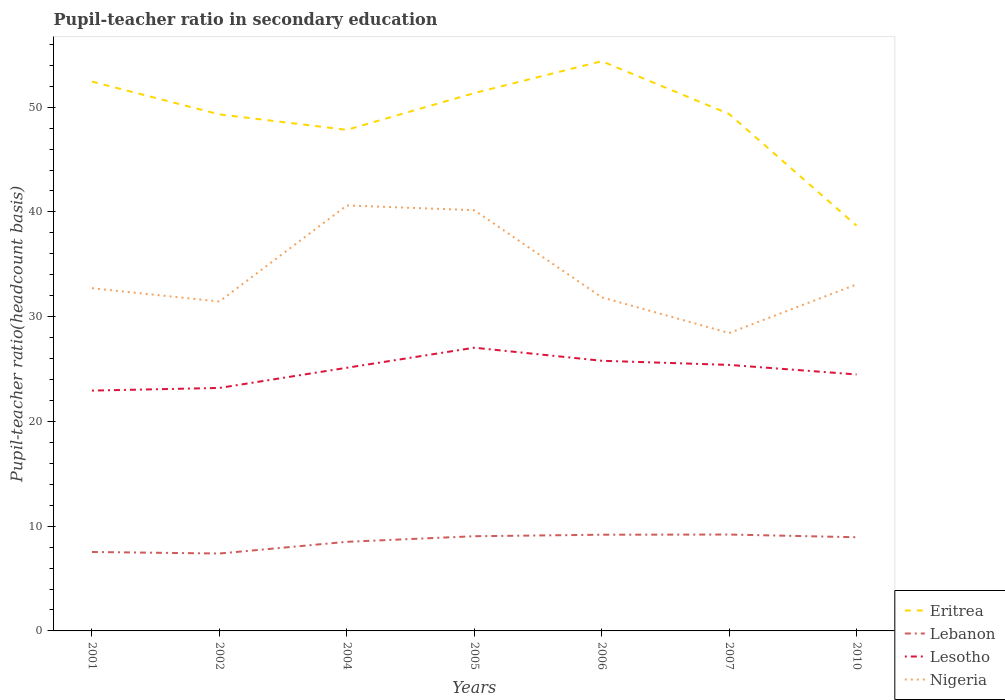How many different coloured lines are there?
Keep it short and to the point. 4. Across all years, what is the maximum pupil-teacher ratio in secondary education in Nigeria?
Your response must be concise. 28.44. In which year was the pupil-teacher ratio in secondary education in Lebanon maximum?
Provide a succinct answer. 2002. What is the total pupil-teacher ratio in secondary education in Lebanon in the graph?
Offer a terse response. -0.68. What is the difference between the highest and the second highest pupil-teacher ratio in secondary education in Nigeria?
Your answer should be very brief. 12.18. What is the difference between the highest and the lowest pupil-teacher ratio in secondary education in Eritrea?
Offer a terse response. 5. Is the pupil-teacher ratio in secondary education in Nigeria strictly greater than the pupil-teacher ratio in secondary education in Eritrea over the years?
Your answer should be compact. Yes. Does the graph contain grids?
Provide a succinct answer. No. How are the legend labels stacked?
Offer a very short reply. Vertical. What is the title of the graph?
Ensure brevity in your answer.  Pupil-teacher ratio in secondary education. Does "Malawi" appear as one of the legend labels in the graph?
Your response must be concise. No. What is the label or title of the Y-axis?
Give a very brief answer. Pupil-teacher ratio(headcount basis). What is the Pupil-teacher ratio(headcount basis) in Eritrea in 2001?
Your answer should be compact. 52.44. What is the Pupil-teacher ratio(headcount basis) in Lebanon in 2001?
Give a very brief answer. 7.54. What is the Pupil-teacher ratio(headcount basis) of Lesotho in 2001?
Offer a very short reply. 22.94. What is the Pupil-teacher ratio(headcount basis) of Nigeria in 2001?
Provide a succinct answer. 32.72. What is the Pupil-teacher ratio(headcount basis) in Eritrea in 2002?
Offer a very short reply. 49.31. What is the Pupil-teacher ratio(headcount basis) of Lebanon in 2002?
Make the answer very short. 7.39. What is the Pupil-teacher ratio(headcount basis) of Lesotho in 2002?
Your answer should be very brief. 23.2. What is the Pupil-teacher ratio(headcount basis) in Nigeria in 2002?
Ensure brevity in your answer.  31.44. What is the Pupil-teacher ratio(headcount basis) of Eritrea in 2004?
Make the answer very short. 47.84. What is the Pupil-teacher ratio(headcount basis) in Lebanon in 2004?
Provide a succinct answer. 8.51. What is the Pupil-teacher ratio(headcount basis) in Lesotho in 2004?
Keep it short and to the point. 25.12. What is the Pupil-teacher ratio(headcount basis) in Nigeria in 2004?
Keep it short and to the point. 40.62. What is the Pupil-teacher ratio(headcount basis) in Eritrea in 2005?
Make the answer very short. 51.35. What is the Pupil-teacher ratio(headcount basis) of Lebanon in 2005?
Ensure brevity in your answer.  9.04. What is the Pupil-teacher ratio(headcount basis) of Lesotho in 2005?
Your answer should be compact. 27.04. What is the Pupil-teacher ratio(headcount basis) in Nigeria in 2005?
Offer a terse response. 40.16. What is the Pupil-teacher ratio(headcount basis) of Eritrea in 2006?
Offer a very short reply. 54.39. What is the Pupil-teacher ratio(headcount basis) of Lebanon in 2006?
Keep it short and to the point. 9.18. What is the Pupil-teacher ratio(headcount basis) in Lesotho in 2006?
Your response must be concise. 25.79. What is the Pupil-teacher ratio(headcount basis) of Nigeria in 2006?
Keep it short and to the point. 31.85. What is the Pupil-teacher ratio(headcount basis) of Eritrea in 2007?
Give a very brief answer. 49.35. What is the Pupil-teacher ratio(headcount basis) of Lebanon in 2007?
Ensure brevity in your answer.  9.2. What is the Pupil-teacher ratio(headcount basis) in Lesotho in 2007?
Give a very brief answer. 25.4. What is the Pupil-teacher ratio(headcount basis) of Nigeria in 2007?
Ensure brevity in your answer.  28.44. What is the Pupil-teacher ratio(headcount basis) of Eritrea in 2010?
Your answer should be very brief. 38.68. What is the Pupil-teacher ratio(headcount basis) in Lebanon in 2010?
Provide a succinct answer. 8.94. What is the Pupil-teacher ratio(headcount basis) of Lesotho in 2010?
Ensure brevity in your answer.  24.48. What is the Pupil-teacher ratio(headcount basis) of Nigeria in 2010?
Your answer should be very brief. 33.08. Across all years, what is the maximum Pupil-teacher ratio(headcount basis) in Eritrea?
Make the answer very short. 54.39. Across all years, what is the maximum Pupil-teacher ratio(headcount basis) in Lebanon?
Your response must be concise. 9.2. Across all years, what is the maximum Pupil-teacher ratio(headcount basis) in Lesotho?
Offer a very short reply. 27.04. Across all years, what is the maximum Pupil-teacher ratio(headcount basis) of Nigeria?
Offer a terse response. 40.62. Across all years, what is the minimum Pupil-teacher ratio(headcount basis) in Eritrea?
Ensure brevity in your answer.  38.68. Across all years, what is the minimum Pupil-teacher ratio(headcount basis) in Lebanon?
Ensure brevity in your answer.  7.39. Across all years, what is the minimum Pupil-teacher ratio(headcount basis) in Lesotho?
Provide a short and direct response. 22.94. Across all years, what is the minimum Pupil-teacher ratio(headcount basis) in Nigeria?
Ensure brevity in your answer.  28.44. What is the total Pupil-teacher ratio(headcount basis) in Eritrea in the graph?
Provide a short and direct response. 343.37. What is the total Pupil-teacher ratio(headcount basis) in Lebanon in the graph?
Keep it short and to the point. 59.8. What is the total Pupil-teacher ratio(headcount basis) in Lesotho in the graph?
Your answer should be compact. 173.97. What is the total Pupil-teacher ratio(headcount basis) of Nigeria in the graph?
Keep it short and to the point. 238.32. What is the difference between the Pupil-teacher ratio(headcount basis) of Eritrea in 2001 and that in 2002?
Your response must be concise. 3.13. What is the difference between the Pupil-teacher ratio(headcount basis) in Lebanon in 2001 and that in 2002?
Give a very brief answer. 0.15. What is the difference between the Pupil-teacher ratio(headcount basis) in Lesotho in 2001 and that in 2002?
Your answer should be compact. -0.25. What is the difference between the Pupil-teacher ratio(headcount basis) of Nigeria in 2001 and that in 2002?
Your answer should be compact. 1.27. What is the difference between the Pupil-teacher ratio(headcount basis) in Eritrea in 2001 and that in 2004?
Your answer should be compact. 4.61. What is the difference between the Pupil-teacher ratio(headcount basis) in Lebanon in 2001 and that in 2004?
Your answer should be compact. -0.97. What is the difference between the Pupil-teacher ratio(headcount basis) in Lesotho in 2001 and that in 2004?
Offer a terse response. -2.18. What is the difference between the Pupil-teacher ratio(headcount basis) in Nigeria in 2001 and that in 2004?
Provide a short and direct response. -7.9. What is the difference between the Pupil-teacher ratio(headcount basis) in Eritrea in 2001 and that in 2005?
Offer a terse response. 1.1. What is the difference between the Pupil-teacher ratio(headcount basis) of Lebanon in 2001 and that in 2005?
Give a very brief answer. -1.5. What is the difference between the Pupil-teacher ratio(headcount basis) of Lesotho in 2001 and that in 2005?
Your answer should be compact. -4.1. What is the difference between the Pupil-teacher ratio(headcount basis) in Nigeria in 2001 and that in 2005?
Your answer should be very brief. -7.45. What is the difference between the Pupil-teacher ratio(headcount basis) in Eritrea in 2001 and that in 2006?
Your answer should be compact. -1.95. What is the difference between the Pupil-teacher ratio(headcount basis) of Lebanon in 2001 and that in 2006?
Your response must be concise. -1.65. What is the difference between the Pupil-teacher ratio(headcount basis) of Lesotho in 2001 and that in 2006?
Your answer should be compact. -2.85. What is the difference between the Pupil-teacher ratio(headcount basis) of Nigeria in 2001 and that in 2006?
Provide a short and direct response. 0.87. What is the difference between the Pupil-teacher ratio(headcount basis) in Eritrea in 2001 and that in 2007?
Your answer should be very brief. 3.1. What is the difference between the Pupil-teacher ratio(headcount basis) of Lebanon in 2001 and that in 2007?
Provide a succinct answer. -1.67. What is the difference between the Pupil-teacher ratio(headcount basis) in Lesotho in 2001 and that in 2007?
Give a very brief answer. -2.45. What is the difference between the Pupil-teacher ratio(headcount basis) in Nigeria in 2001 and that in 2007?
Give a very brief answer. 4.28. What is the difference between the Pupil-teacher ratio(headcount basis) in Eritrea in 2001 and that in 2010?
Your answer should be very brief. 13.76. What is the difference between the Pupil-teacher ratio(headcount basis) in Lebanon in 2001 and that in 2010?
Make the answer very short. -1.41. What is the difference between the Pupil-teacher ratio(headcount basis) of Lesotho in 2001 and that in 2010?
Keep it short and to the point. -1.54. What is the difference between the Pupil-teacher ratio(headcount basis) of Nigeria in 2001 and that in 2010?
Provide a short and direct response. -0.36. What is the difference between the Pupil-teacher ratio(headcount basis) of Eritrea in 2002 and that in 2004?
Offer a terse response. 1.48. What is the difference between the Pupil-teacher ratio(headcount basis) of Lebanon in 2002 and that in 2004?
Your answer should be compact. -1.12. What is the difference between the Pupil-teacher ratio(headcount basis) in Lesotho in 2002 and that in 2004?
Provide a short and direct response. -1.93. What is the difference between the Pupil-teacher ratio(headcount basis) in Nigeria in 2002 and that in 2004?
Keep it short and to the point. -9.17. What is the difference between the Pupil-teacher ratio(headcount basis) in Eritrea in 2002 and that in 2005?
Offer a very short reply. -2.03. What is the difference between the Pupil-teacher ratio(headcount basis) of Lebanon in 2002 and that in 2005?
Provide a succinct answer. -1.65. What is the difference between the Pupil-teacher ratio(headcount basis) of Lesotho in 2002 and that in 2005?
Offer a terse response. -3.84. What is the difference between the Pupil-teacher ratio(headcount basis) in Nigeria in 2002 and that in 2005?
Make the answer very short. -8.72. What is the difference between the Pupil-teacher ratio(headcount basis) in Eritrea in 2002 and that in 2006?
Your answer should be compact. -5.08. What is the difference between the Pupil-teacher ratio(headcount basis) of Lebanon in 2002 and that in 2006?
Your answer should be very brief. -1.79. What is the difference between the Pupil-teacher ratio(headcount basis) in Lesotho in 2002 and that in 2006?
Keep it short and to the point. -2.59. What is the difference between the Pupil-teacher ratio(headcount basis) in Nigeria in 2002 and that in 2006?
Make the answer very short. -0.41. What is the difference between the Pupil-teacher ratio(headcount basis) in Eritrea in 2002 and that in 2007?
Your response must be concise. -0.04. What is the difference between the Pupil-teacher ratio(headcount basis) in Lebanon in 2002 and that in 2007?
Provide a succinct answer. -1.81. What is the difference between the Pupil-teacher ratio(headcount basis) in Lesotho in 2002 and that in 2007?
Ensure brevity in your answer.  -2.2. What is the difference between the Pupil-teacher ratio(headcount basis) in Nigeria in 2002 and that in 2007?
Offer a very short reply. 3. What is the difference between the Pupil-teacher ratio(headcount basis) in Eritrea in 2002 and that in 2010?
Provide a short and direct response. 10.63. What is the difference between the Pupil-teacher ratio(headcount basis) in Lebanon in 2002 and that in 2010?
Your answer should be very brief. -1.55. What is the difference between the Pupil-teacher ratio(headcount basis) in Lesotho in 2002 and that in 2010?
Provide a succinct answer. -1.29. What is the difference between the Pupil-teacher ratio(headcount basis) in Nigeria in 2002 and that in 2010?
Keep it short and to the point. -1.64. What is the difference between the Pupil-teacher ratio(headcount basis) in Eritrea in 2004 and that in 2005?
Give a very brief answer. -3.51. What is the difference between the Pupil-teacher ratio(headcount basis) in Lebanon in 2004 and that in 2005?
Your answer should be compact. -0.53. What is the difference between the Pupil-teacher ratio(headcount basis) of Lesotho in 2004 and that in 2005?
Offer a very short reply. -1.91. What is the difference between the Pupil-teacher ratio(headcount basis) of Nigeria in 2004 and that in 2005?
Provide a succinct answer. 0.45. What is the difference between the Pupil-teacher ratio(headcount basis) in Eritrea in 2004 and that in 2006?
Your answer should be compact. -6.55. What is the difference between the Pupil-teacher ratio(headcount basis) in Lebanon in 2004 and that in 2006?
Your answer should be very brief. -0.68. What is the difference between the Pupil-teacher ratio(headcount basis) of Lesotho in 2004 and that in 2006?
Provide a short and direct response. -0.67. What is the difference between the Pupil-teacher ratio(headcount basis) in Nigeria in 2004 and that in 2006?
Ensure brevity in your answer.  8.77. What is the difference between the Pupil-teacher ratio(headcount basis) in Eritrea in 2004 and that in 2007?
Provide a succinct answer. -1.51. What is the difference between the Pupil-teacher ratio(headcount basis) of Lebanon in 2004 and that in 2007?
Offer a very short reply. -0.7. What is the difference between the Pupil-teacher ratio(headcount basis) of Lesotho in 2004 and that in 2007?
Offer a very short reply. -0.27. What is the difference between the Pupil-teacher ratio(headcount basis) of Nigeria in 2004 and that in 2007?
Offer a terse response. 12.18. What is the difference between the Pupil-teacher ratio(headcount basis) in Eritrea in 2004 and that in 2010?
Offer a terse response. 9.15. What is the difference between the Pupil-teacher ratio(headcount basis) of Lebanon in 2004 and that in 2010?
Ensure brevity in your answer.  -0.43. What is the difference between the Pupil-teacher ratio(headcount basis) of Lesotho in 2004 and that in 2010?
Provide a short and direct response. 0.64. What is the difference between the Pupil-teacher ratio(headcount basis) in Nigeria in 2004 and that in 2010?
Offer a terse response. 7.54. What is the difference between the Pupil-teacher ratio(headcount basis) of Eritrea in 2005 and that in 2006?
Make the answer very short. -3.04. What is the difference between the Pupil-teacher ratio(headcount basis) of Lebanon in 2005 and that in 2006?
Provide a succinct answer. -0.14. What is the difference between the Pupil-teacher ratio(headcount basis) in Lesotho in 2005 and that in 2006?
Provide a succinct answer. 1.25. What is the difference between the Pupil-teacher ratio(headcount basis) of Nigeria in 2005 and that in 2006?
Your answer should be compact. 8.31. What is the difference between the Pupil-teacher ratio(headcount basis) in Eritrea in 2005 and that in 2007?
Provide a short and direct response. 2. What is the difference between the Pupil-teacher ratio(headcount basis) in Lebanon in 2005 and that in 2007?
Your answer should be very brief. -0.16. What is the difference between the Pupil-teacher ratio(headcount basis) of Lesotho in 2005 and that in 2007?
Provide a succinct answer. 1.64. What is the difference between the Pupil-teacher ratio(headcount basis) in Nigeria in 2005 and that in 2007?
Your answer should be very brief. 11.72. What is the difference between the Pupil-teacher ratio(headcount basis) in Eritrea in 2005 and that in 2010?
Your response must be concise. 12.66. What is the difference between the Pupil-teacher ratio(headcount basis) in Lebanon in 2005 and that in 2010?
Make the answer very short. 0.1. What is the difference between the Pupil-teacher ratio(headcount basis) of Lesotho in 2005 and that in 2010?
Your answer should be compact. 2.55. What is the difference between the Pupil-teacher ratio(headcount basis) of Nigeria in 2005 and that in 2010?
Your response must be concise. 7.08. What is the difference between the Pupil-teacher ratio(headcount basis) of Eritrea in 2006 and that in 2007?
Ensure brevity in your answer.  5.04. What is the difference between the Pupil-teacher ratio(headcount basis) in Lebanon in 2006 and that in 2007?
Keep it short and to the point. -0.02. What is the difference between the Pupil-teacher ratio(headcount basis) of Lesotho in 2006 and that in 2007?
Give a very brief answer. 0.4. What is the difference between the Pupil-teacher ratio(headcount basis) in Nigeria in 2006 and that in 2007?
Your response must be concise. 3.41. What is the difference between the Pupil-teacher ratio(headcount basis) of Eritrea in 2006 and that in 2010?
Your response must be concise. 15.71. What is the difference between the Pupil-teacher ratio(headcount basis) of Lebanon in 2006 and that in 2010?
Your response must be concise. 0.24. What is the difference between the Pupil-teacher ratio(headcount basis) of Lesotho in 2006 and that in 2010?
Provide a short and direct response. 1.31. What is the difference between the Pupil-teacher ratio(headcount basis) in Nigeria in 2006 and that in 2010?
Provide a succinct answer. -1.23. What is the difference between the Pupil-teacher ratio(headcount basis) in Eritrea in 2007 and that in 2010?
Give a very brief answer. 10.66. What is the difference between the Pupil-teacher ratio(headcount basis) of Lebanon in 2007 and that in 2010?
Provide a succinct answer. 0.26. What is the difference between the Pupil-teacher ratio(headcount basis) in Lesotho in 2007 and that in 2010?
Provide a succinct answer. 0.91. What is the difference between the Pupil-teacher ratio(headcount basis) of Nigeria in 2007 and that in 2010?
Offer a very short reply. -4.64. What is the difference between the Pupil-teacher ratio(headcount basis) of Eritrea in 2001 and the Pupil-teacher ratio(headcount basis) of Lebanon in 2002?
Provide a succinct answer. 45.05. What is the difference between the Pupil-teacher ratio(headcount basis) of Eritrea in 2001 and the Pupil-teacher ratio(headcount basis) of Lesotho in 2002?
Ensure brevity in your answer.  29.25. What is the difference between the Pupil-teacher ratio(headcount basis) of Eritrea in 2001 and the Pupil-teacher ratio(headcount basis) of Nigeria in 2002?
Keep it short and to the point. 21. What is the difference between the Pupil-teacher ratio(headcount basis) in Lebanon in 2001 and the Pupil-teacher ratio(headcount basis) in Lesotho in 2002?
Provide a succinct answer. -15.66. What is the difference between the Pupil-teacher ratio(headcount basis) in Lebanon in 2001 and the Pupil-teacher ratio(headcount basis) in Nigeria in 2002?
Keep it short and to the point. -23.91. What is the difference between the Pupil-teacher ratio(headcount basis) of Lesotho in 2001 and the Pupil-teacher ratio(headcount basis) of Nigeria in 2002?
Your answer should be compact. -8.5. What is the difference between the Pupil-teacher ratio(headcount basis) of Eritrea in 2001 and the Pupil-teacher ratio(headcount basis) of Lebanon in 2004?
Your answer should be compact. 43.94. What is the difference between the Pupil-teacher ratio(headcount basis) of Eritrea in 2001 and the Pupil-teacher ratio(headcount basis) of Lesotho in 2004?
Offer a terse response. 27.32. What is the difference between the Pupil-teacher ratio(headcount basis) in Eritrea in 2001 and the Pupil-teacher ratio(headcount basis) in Nigeria in 2004?
Ensure brevity in your answer.  11.82. What is the difference between the Pupil-teacher ratio(headcount basis) of Lebanon in 2001 and the Pupil-teacher ratio(headcount basis) of Lesotho in 2004?
Provide a short and direct response. -17.59. What is the difference between the Pupil-teacher ratio(headcount basis) of Lebanon in 2001 and the Pupil-teacher ratio(headcount basis) of Nigeria in 2004?
Ensure brevity in your answer.  -33.08. What is the difference between the Pupil-teacher ratio(headcount basis) in Lesotho in 2001 and the Pupil-teacher ratio(headcount basis) in Nigeria in 2004?
Offer a terse response. -17.68. What is the difference between the Pupil-teacher ratio(headcount basis) in Eritrea in 2001 and the Pupil-teacher ratio(headcount basis) in Lebanon in 2005?
Offer a very short reply. 43.4. What is the difference between the Pupil-teacher ratio(headcount basis) of Eritrea in 2001 and the Pupil-teacher ratio(headcount basis) of Lesotho in 2005?
Your response must be concise. 25.41. What is the difference between the Pupil-teacher ratio(headcount basis) in Eritrea in 2001 and the Pupil-teacher ratio(headcount basis) in Nigeria in 2005?
Give a very brief answer. 12.28. What is the difference between the Pupil-teacher ratio(headcount basis) of Lebanon in 2001 and the Pupil-teacher ratio(headcount basis) of Lesotho in 2005?
Your response must be concise. -19.5. What is the difference between the Pupil-teacher ratio(headcount basis) in Lebanon in 2001 and the Pupil-teacher ratio(headcount basis) in Nigeria in 2005?
Offer a very short reply. -32.63. What is the difference between the Pupil-teacher ratio(headcount basis) in Lesotho in 2001 and the Pupil-teacher ratio(headcount basis) in Nigeria in 2005?
Your answer should be very brief. -17.22. What is the difference between the Pupil-teacher ratio(headcount basis) in Eritrea in 2001 and the Pupil-teacher ratio(headcount basis) in Lebanon in 2006?
Give a very brief answer. 43.26. What is the difference between the Pupil-teacher ratio(headcount basis) in Eritrea in 2001 and the Pupil-teacher ratio(headcount basis) in Lesotho in 2006?
Keep it short and to the point. 26.65. What is the difference between the Pupil-teacher ratio(headcount basis) in Eritrea in 2001 and the Pupil-teacher ratio(headcount basis) in Nigeria in 2006?
Provide a succinct answer. 20.59. What is the difference between the Pupil-teacher ratio(headcount basis) in Lebanon in 2001 and the Pupil-teacher ratio(headcount basis) in Lesotho in 2006?
Provide a short and direct response. -18.26. What is the difference between the Pupil-teacher ratio(headcount basis) of Lebanon in 2001 and the Pupil-teacher ratio(headcount basis) of Nigeria in 2006?
Give a very brief answer. -24.31. What is the difference between the Pupil-teacher ratio(headcount basis) in Lesotho in 2001 and the Pupil-teacher ratio(headcount basis) in Nigeria in 2006?
Keep it short and to the point. -8.91. What is the difference between the Pupil-teacher ratio(headcount basis) of Eritrea in 2001 and the Pupil-teacher ratio(headcount basis) of Lebanon in 2007?
Provide a succinct answer. 43.24. What is the difference between the Pupil-teacher ratio(headcount basis) of Eritrea in 2001 and the Pupil-teacher ratio(headcount basis) of Lesotho in 2007?
Keep it short and to the point. 27.05. What is the difference between the Pupil-teacher ratio(headcount basis) in Eritrea in 2001 and the Pupil-teacher ratio(headcount basis) in Nigeria in 2007?
Your answer should be compact. 24. What is the difference between the Pupil-teacher ratio(headcount basis) in Lebanon in 2001 and the Pupil-teacher ratio(headcount basis) in Lesotho in 2007?
Your answer should be very brief. -17.86. What is the difference between the Pupil-teacher ratio(headcount basis) in Lebanon in 2001 and the Pupil-teacher ratio(headcount basis) in Nigeria in 2007?
Your answer should be very brief. -20.9. What is the difference between the Pupil-teacher ratio(headcount basis) of Lesotho in 2001 and the Pupil-teacher ratio(headcount basis) of Nigeria in 2007?
Your answer should be compact. -5.5. What is the difference between the Pupil-teacher ratio(headcount basis) of Eritrea in 2001 and the Pupil-teacher ratio(headcount basis) of Lebanon in 2010?
Ensure brevity in your answer.  43.5. What is the difference between the Pupil-teacher ratio(headcount basis) in Eritrea in 2001 and the Pupil-teacher ratio(headcount basis) in Lesotho in 2010?
Your answer should be compact. 27.96. What is the difference between the Pupil-teacher ratio(headcount basis) in Eritrea in 2001 and the Pupil-teacher ratio(headcount basis) in Nigeria in 2010?
Offer a very short reply. 19.36. What is the difference between the Pupil-teacher ratio(headcount basis) of Lebanon in 2001 and the Pupil-teacher ratio(headcount basis) of Lesotho in 2010?
Provide a short and direct response. -16.95. What is the difference between the Pupil-teacher ratio(headcount basis) of Lebanon in 2001 and the Pupil-teacher ratio(headcount basis) of Nigeria in 2010?
Offer a terse response. -25.54. What is the difference between the Pupil-teacher ratio(headcount basis) of Lesotho in 2001 and the Pupil-teacher ratio(headcount basis) of Nigeria in 2010?
Provide a succinct answer. -10.14. What is the difference between the Pupil-teacher ratio(headcount basis) of Eritrea in 2002 and the Pupil-teacher ratio(headcount basis) of Lebanon in 2004?
Keep it short and to the point. 40.81. What is the difference between the Pupil-teacher ratio(headcount basis) of Eritrea in 2002 and the Pupil-teacher ratio(headcount basis) of Lesotho in 2004?
Your answer should be very brief. 24.19. What is the difference between the Pupil-teacher ratio(headcount basis) in Eritrea in 2002 and the Pupil-teacher ratio(headcount basis) in Nigeria in 2004?
Your response must be concise. 8.69. What is the difference between the Pupil-teacher ratio(headcount basis) in Lebanon in 2002 and the Pupil-teacher ratio(headcount basis) in Lesotho in 2004?
Make the answer very short. -17.73. What is the difference between the Pupil-teacher ratio(headcount basis) of Lebanon in 2002 and the Pupil-teacher ratio(headcount basis) of Nigeria in 2004?
Your response must be concise. -33.23. What is the difference between the Pupil-teacher ratio(headcount basis) in Lesotho in 2002 and the Pupil-teacher ratio(headcount basis) in Nigeria in 2004?
Your response must be concise. -17.42. What is the difference between the Pupil-teacher ratio(headcount basis) of Eritrea in 2002 and the Pupil-teacher ratio(headcount basis) of Lebanon in 2005?
Provide a short and direct response. 40.27. What is the difference between the Pupil-teacher ratio(headcount basis) of Eritrea in 2002 and the Pupil-teacher ratio(headcount basis) of Lesotho in 2005?
Offer a very short reply. 22.28. What is the difference between the Pupil-teacher ratio(headcount basis) in Eritrea in 2002 and the Pupil-teacher ratio(headcount basis) in Nigeria in 2005?
Give a very brief answer. 9.15. What is the difference between the Pupil-teacher ratio(headcount basis) of Lebanon in 2002 and the Pupil-teacher ratio(headcount basis) of Lesotho in 2005?
Your response must be concise. -19.65. What is the difference between the Pupil-teacher ratio(headcount basis) in Lebanon in 2002 and the Pupil-teacher ratio(headcount basis) in Nigeria in 2005?
Offer a very short reply. -32.77. What is the difference between the Pupil-teacher ratio(headcount basis) of Lesotho in 2002 and the Pupil-teacher ratio(headcount basis) of Nigeria in 2005?
Ensure brevity in your answer.  -16.97. What is the difference between the Pupil-teacher ratio(headcount basis) of Eritrea in 2002 and the Pupil-teacher ratio(headcount basis) of Lebanon in 2006?
Your response must be concise. 40.13. What is the difference between the Pupil-teacher ratio(headcount basis) in Eritrea in 2002 and the Pupil-teacher ratio(headcount basis) in Lesotho in 2006?
Your response must be concise. 23.52. What is the difference between the Pupil-teacher ratio(headcount basis) of Eritrea in 2002 and the Pupil-teacher ratio(headcount basis) of Nigeria in 2006?
Your answer should be compact. 17.46. What is the difference between the Pupil-teacher ratio(headcount basis) in Lebanon in 2002 and the Pupil-teacher ratio(headcount basis) in Lesotho in 2006?
Keep it short and to the point. -18.4. What is the difference between the Pupil-teacher ratio(headcount basis) in Lebanon in 2002 and the Pupil-teacher ratio(headcount basis) in Nigeria in 2006?
Ensure brevity in your answer.  -24.46. What is the difference between the Pupil-teacher ratio(headcount basis) in Lesotho in 2002 and the Pupil-teacher ratio(headcount basis) in Nigeria in 2006?
Your answer should be compact. -8.65. What is the difference between the Pupil-teacher ratio(headcount basis) of Eritrea in 2002 and the Pupil-teacher ratio(headcount basis) of Lebanon in 2007?
Your answer should be very brief. 40.11. What is the difference between the Pupil-teacher ratio(headcount basis) in Eritrea in 2002 and the Pupil-teacher ratio(headcount basis) in Lesotho in 2007?
Ensure brevity in your answer.  23.92. What is the difference between the Pupil-teacher ratio(headcount basis) in Eritrea in 2002 and the Pupil-teacher ratio(headcount basis) in Nigeria in 2007?
Offer a very short reply. 20.87. What is the difference between the Pupil-teacher ratio(headcount basis) of Lebanon in 2002 and the Pupil-teacher ratio(headcount basis) of Lesotho in 2007?
Make the answer very short. -18.01. What is the difference between the Pupil-teacher ratio(headcount basis) of Lebanon in 2002 and the Pupil-teacher ratio(headcount basis) of Nigeria in 2007?
Offer a terse response. -21.05. What is the difference between the Pupil-teacher ratio(headcount basis) of Lesotho in 2002 and the Pupil-teacher ratio(headcount basis) of Nigeria in 2007?
Keep it short and to the point. -5.24. What is the difference between the Pupil-teacher ratio(headcount basis) in Eritrea in 2002 and the Pupil-teacher ratio(headcount basis) in Lebanon in 2010?
Make the answer very short. 40.37. What is the difference between the Pupil-teacher ratio(headcount basis) in Eritrea in 2002 and the Pupil-teacher ratio(headcount basis) in Lesotho in 2010?
Give a very brief answer. 24.83. What is the difference between the Pupil-teacher ratio(headcount basis) in Eritrea in 2002 and the Pupil-teacher ratio(headcount basis) in Nigeria in 2010?
Provide a short and direct response. 16.23. What is the difference between the Pupil-teacher ratio(headcount basis) of Lebanon in 2002 and the Pupil-teacher ratio(headcount basis) of Lesotho in 2010?
Your response must be concise. -17.09. What is the difference between the Pupil-teacher ratio(headcount basis) of Lebanon in 2002 and the Pupil-teacher ratio(headcount basis) of Nigeria in 2010?
Offer a very short reply. -25.69. What is the difference between the Pupil-teacher ratio(headcount basis) of Lesotho in 2002 and the Pupil-teacher ratio(headcount basis) of Nigeria in 2010?
Ensure brevity in your answer.  -9.88. What is the difference between the Pupil-teacher ratio(headcount basis) in Eritrea in 2004 and the Pupil-teacher ratio(headcount basis) in Lebanon in 2005?
Offer a terse response. 38.8. What is the difference between the Pupil-teacher ratio(headcount basis) in Eritrea in 2004 and the Pupil-teacher ratio(headcount basis) in Lesotho in 2005?
Offer a terse response. 20.8. What is the difference between the Pupil-teacher ratio(headcount basis) in Eritrea in 2004 and the Pupil-teacher ratio(headcount basis) in Nigeria in 2005?
Your answer should be very brief. 7.67. What is the difference between the Pupil-teacher ratio(headcount basis) in Lebanon in 2004 and the Pupil-teacher ratio(headcount basis) in Lesotho in 2005?
Your answer should be compact. -18.53. What is the difference between the Pupil-teacher ratio(headcount basis) in Lebanon in 2004 and the Pupil-teacher ratio(headcount basis) in Nigeria in 2005?
Your answer should be compact. -31.66. What is the difference between the Pupil-teacher ratio(headcount basis) in Lesotho in 2004 and the Pupil-teacher ratio(headcount basis) in Nigeria in 2005?
Give a very brief answer. -15.04. What is the difference between the Pupil-teacher ratio(headcount basis) in Eritrea in 2004 and the Pupil-teacher ratio(headcount basis) in Lebanon in 2006?
Your answer should be very brief. 38.65. What is the difference between the Pupil-teacher ratio(headcount basis) of Eritrea in 2004 and the Pupil-teacher ratio(headcount basis) of Lesotho in 2006?
Offer a very short reply. 22.05. What is the difference between the Pupil-teacher ratio(headcount basis) in Eritrea in 2004 and the Pupil-teacher ratio(headcount basis) in Nigeria in 2006?
Make the answer very short. 15.99. What is the difference between the Pupil-teacher ratio(headcount basis) of Lebanon in 2004 and the Pupil-teacher ratio(headcount basis) of Lesotho in 2006?
Your response must be concise. -17.28. What is the difference between the Pupil-teacher ratio(headcount basis) in Lebanon in 2004 and the Pupil-teacher ratio(headcount basis) in Nigeria in 2006?
Provide a succinct answer. -23.34. What is the difference between the Pupil-teacher ratio(headcount basis) in Lesotho in 2004 and the Pupil-teacher ratio(headcount basis) in Nigeria in 2006?
Your answer should be very brief. -6.73. What is the difference between the Pupil-teacher ratio(headcount basis) in Eritrea in 2004 and the Pupil-teacher ratio(headcount basis) in Lebanon in 2007?
Make the answer very short. 38.64. What is the difference between the Pupil-teacher ratio(headcount basis) of Eritrea in 2004 and the Pupil-teacher ratio(headcount basis) of Lesotho in 2007?
Provide a succinct answer. 22.44. What is the difference between the Pupil-teacher ratio(headcount basis) in Eritrea in 2004 and the Pupil-teacher ratio(headcount basis) in Nigeria in 2007?
Your answer should be compact. 19.4. What is the difference between the Pupil-teacher ratio(headcount basis) in Lebanon in 2004 and the Pupil-teacher ratio(headcount basis) in Lesotho in 2007?
Your response must be concise. -16.89. What is the difference between the Pupil-teacher ratio(headcount basis) of Lebanon in 2004 and the Pupil-teacher ratio(headcount basis) of Nigeria in 2007?
Offer a very short reply. -19.93. What is the difference between the Pupil-teacher ratio(headcount basis) in Lesotho in 2004 and the Pupil-teacher ratio(headcount basis) in Nigeria in 2007?
Provide a short and direct response. -3.32. What is the difference between the Pupil-teacher ratio(headcount basis) in Eritrea in 2004 and the Pupil-teacher ratio(headcount basis) in Lebanon in 2010?
Your answer should be compact. 38.9. What is the difference between the Pupil-teacher ratio(headcount basis) of Eritrea in 2004 and the Pupil-teacher ratio(headcount basis) of Lesotho in 2010?
Your response must be concise. 23.35. What is the difference between the Pupil-teacher ratio(headcount basis) in Eritrea in 2004 and the Pupil-teacher ratio(headcount basis) in Nigeria in 2010?
Provide a short and direct response. 14.76. What is the difference between the Pupil-teacher ratio(headcount basis) of Lebanon in 2004 and the Pupil-teacher ratio(headcount basis) of Lesotho in 2010?
Provide a succinct answer. -15.98. What is the difference between the Pupil-teacher ratio(headcount basis) of Lebanon in 2004 and the Pupil-teacher ratio(headcount basis) of Nigeria in 2010?
Your response must be concise. -24.57. What is the difference between the Pupil-teacher ratio(headcount basis) in Lesotho in 2004 and the Pupil-teacher ratio(headcount basis) in Nigeria in 2010?
Your answer should be very brief. -7.96. What is the difference between the Pupil-teacher ratio(headcount basis) in Eritrea in 2005 and the Pupil-teacher ratio(headcount basis) in Lebanon in 2006?
Provide a short and direct response. 42.16. What is the difference between the Pupil-teacher ratio(headcount basis) in Eritrea in 2005 and the Pupil-teacher ratio(headcount basis) in Lesotho in 2006?
Give a very brief answer. 25.56. What is the difference between the Pupil-teacher ratio(headcount basis) of Eritrea in 2005 and the Pupil-teacher ratio(headcount basis) of Nigeria in 2006?
Make the answer very short. 19.5. What is the difference between the Pupil-teacher ratio(headcount basis) of Lebanon in 2005 and the Pupil-teacher ratio(headcount basis) of Lesotho in 2006?
Provide a succinct answer. -16.75. What is the difference between the Pupil-teacher ratio(headcount basis) of Lebanon in 2005 and the Pupil-teacher ratio(headcount basis) of Nigeria in 2006?
Offer a very short reply. -22.81. What is the difference between the Pupil-teacher ratio(headcount basis) of Lesotho in 2005 and the Pupil-teacher ratio(headcount basis) of Nigeria in 2006?
Provide a short and direct response. -4.81. What is the difference between the Pupil-teacher ratio(headcount basis) in Eritrea in 2005 and the Pupil-teacher ratio(headcount basis) in Lebanon in 2007?
Your answer should be very brief. 42.15. What is the difference between the Pupil-teacher ratio(headcount basis) of Eritrea in 2005 and the Pupil-teacher ratio(headcount basis) of Lesotho in 2007?
Give a very brief answer. 25.95. What is the difference between the Pupil-teacher ratio(headcount basis) of Eritrea in 2005 and the Pupil-teacher ratio(headcount basis) of Nigeria in 2007?
Ensure brevity in your answer.  22.91. What is the difference between the Pupil-teacher ratio(headcount basis) in Lebanon in 2005 and the Pupil-teacher ratio(headcount basis) in Lesotho in 2007?
Offer a very short reply. -16.36. What is the difference between the Pupil-teacher ratio(headcount basis) of Lebanon in 2005 and the Pupil-teacher ratio(headcount basis) of Nigeria in 2007?
Your answer should be very brief. -19.4. What is the difference between the Pupil-teacher ratio(headcount basis) in Lesotho in 2005 and the Pupil-teacher ratio(headcount basis) in Nigeria in 2007?
Keep it short and to the point. -1.4. What is the difference between the Pupil-teacher ratio(headcount basis) of Eritrea in 2005 and the Pupil-teacher ratio(headcount basis) of Lebanon in 2010?
Provide a succinct answer. 42.41. What is the difference between the Pupil-teacher ratio(headcount basis) of Eritrea in 2005 and the Pupil-teacher ratio(headcount basis) of Lesotho in 2010?
Provide a succinct answer. 26.86. What is the difference between the Pupil-teacher ratio(headcount basis) in Eritrea in 2005 and the Pupil-teacher ratio(headcount basis) in Nigeria in 2010?
Offer a terse response. 18.27. What is the difference between the Pupil-teacher ratio(headcount basis) of Lebanon in 2005 and the Pupil-teacher ratio(headcount basis) of Lesotho in 2010?
Keep it short and to the point. -15.44. What is the difference between the Pupil-teacher ratio(headcount basis) in Lebanon in 2005 and the Pupil-teacher ratio(headcount basis) in Nigeria in 2010?
Make the answer very short. -24.04. What is the difference between the Pupil-teacher ratio(headcount basis) in Lesotho in 2005 and the Pupil-teacher ratio(headcount basis) in Nigeria in 2010?
Provide a succinct answer. -6.04. What is the difference between the Pupil-teacher ratio(headcount basis) in Eritrea in 2006 and the Pupil-teacher ratio(headcount basis) in Lebanon in 2007?
Provide a short and direct response. 45.19. What is the difference between the Pupil-teacher ratio(headcount basis) in Eritrea in 2006 and the Pupil-teacher ratio(headcount basis) in Lesotho in 2007?
Your response must be concise. 28.99. What is the difference between the Pupil-teacher ratio(headcount basis) in Eritrea in 2006 and the Pupil-teacher ratio(headcount basis) in Nigeria in 2007?
Provide a succinct answer. 25.95. What is the difference between the Pupil-teacher ratio(headcount basis) in Lebanon in 2006 and the Pupil-teacher ratio(headcount basis) in Lesotho in 2007?
Offer a very short reply. -16.21. What is the difference between the Pupil-teacher ratio(headcount basis) of Lebanon in 2006 and the Pupil-teacher ratio(headcount basis) of Nigeria in 2007?
Make the answer very short. -19.26. What is the difference between the Pupil-teacher ratio(headcount basis) of Lesotho in 2006 and the Pupil-teacher ratio(headcount basis) of Nigeria in 2007?
Ensure brevity in your answer.  -2.65. What is the difference between the Pupil-teacher ratio(headcount basis) of Eritrea in 2006 and the Pupil-teacher ratio(headcount basis) of Lebanon in 2010?
Give a very brief answer. 45.45. What is the difference between the Pupil-teacher ratio(headcount basis) of Eritrea in 2006 and the Pupil-teacher ratio(headcount basis) of Lesotho in 2010?
Offer a terse response. 29.91. What is the difference between the Pupil-teacher ratio(headcount basis) of Eritrea in 2006 and the Pupil-teacher ratio(headcount basis) of Nigeria in 2010?
Keep it short and to the point. 21.31. What is the difference between the Pupil-teacher ratio(headcount basis) in Lebanon in 2006 and the Pupil-teacher ratio(headcount basis) in Lesotho in 2010?
Your answer should be very brief. -15.3. What is the difference between the Pupil-teacher ratio(headcount basis) in Lebanon in 2006 and the Pupil-teacher ratio(headcount basis) in Nigeria in 2010?
Offer a very short reply. -23.9. What is the difference between the Pupil-teacher ratio(headcount basis) of Lesotho in 2006 and the Pupil-teacher ratio(headcount basis) of Nigeria in 2010?
Offer a very short reply. -7.29. What is the difference between the Pupil-teacher ratio(headcount basis) in Eritrea in 2007 and the Pupil-teacher ratio(headcount basis) in Lebanon in 2010?
Provide a succinct answer. 40.41. What is the difference between the Pupil-teacher ratio(headcount basis) in Eritrea in 2007 and the Pupil-teacher ratio(headcount basis) in Lesotho in 2010?
Provide a short and direct response. 24.86. What is the difference between the Pupil-teacher ratio(headcount basis) in Eritrea in 2007 and the Pupil-teacher ratio(headcount basis) in Nigeria in 2010?
Your response must be concise. 16.27. What is the difference between the Pupil-teacher ratio(headcount basis) of Lebanon in 2007 and the Pupil-teacher ratio(headcount basis) of Lesotho in 2010?
Your response must be concise. -15.28. What is the difference between the Pupil-teacher ratio(headcount basis) in Lebanon in 2007 and the Pupil-teacher ratio(headcount basis) in Nigeria in 2010?
Provide a short and direct response. -23.88. What is the difference between the Pupil-teacher ratio(headcount basis) in Lesotho in 2007 and the Pupil-teacher ratio(headcount basis) in Nigeria in 2010?
Offer a very short reply. -7.68. What is the average Pupil-teacher ratio(headcount basis) of Eritrea per year?
Ensure brevity in your answer.  49.05. What is the average Pupil-teacher ratio(headcount basis) of Lebanon per year?
Your answer should be very brief. 8.54. What is the average Pupil-teacher ratio(headcount basis) in Lesotho per year?
Ensure brevity in your answer.  24.85. What is the average Pupil-teacher ratio(headcount basis) of Nigeria per year?
Make the answer very short. 34.05. In the year 2001, what is the difference between the Pupil-teacher ratio(headcount basis) in Eritrea and Pupil-teacher ratio(headcount basis) in Lebanon?
Your answer should be very brief. 44.91. In the year 2001, what is the difference between the Pupil-teacher ratio(headcount basis) of Eritrea and Pupil-teacher ratio(headcount basis) of Lesotho?
Ensure brevity in your answer.  29.5. In the year 2001, what is the difference between the Pupil-teacher ratio(headcount basis) in Eritrea and Pupil-teacher ratio(headcount basis) in Nigeria?
Your answer should be very brief. 19.73. In the year 2001, what is the difference between the Pupil-teacher ratio(headcount basis) of Lebanon and Pupil-teacher ratio(headcount basis) of Lesotho?
Make the answer very short. -15.41. In the year 2001, what is the difference between the Pupil-teacher ratio(headcount basis) in Lebanon and Pupil-teacher ratio(headcount basis) in Nigeria?
Ensure brevity in your answer.  -25.18. In the year 2001, what is the difference between the Pupil-teacher ratio(headcount basis) in Lesotho and Pupil-teacher ratio(headcount basis) in Nigeria?
Ensure brevity in your answer.  -9.78. In the year 2002, what is the difference between the Pupil-teacher ratio(headcount basis) in Eritrea and Pupil-teacher ratio(headcount basis) in Lebanon?
Your answer should be very brief. 41.92. In the year 2002, what is the difference between the Pupil-teacher ratio(headcount basis) in Eritrea and Pupil-teacher ratio(headcount basis) in Lesotho?
Keep it short and to the point. 26.12. In the year 2002, what is the difference between the Pupil-teacher ratio(headcount basis) in Eritrea and Pupil-teacher ratio(headcount basis) in Nigeria?
Give a very brief answer. 17.87. In the year 2002, what is the difference between the Pupil-teacher ratio(headcount basis) of Lebanon and Pupil-teacher ratio(headcount basis) of Lesotho?
Offer a very short reply. -15.81. In the year 2002, what is the difference between the Pupil-teacher ratio(headcount basis) of Lebanon and Pupil-teacher ratio(headcount basis) of Nigeria?
Offer a terse response. -24.05. In the year 2002, what is the difference between the Pupil-teacher ratio(headcount basis) of Lesotho and Pupil-teacher ratio(headcount basis) of Nigeria?
Your answer should be compact. -8.25. In the year 2004, what is the difference between the Pupil-teacher ratio(headcount basis) of Eritrea and Pupil-teacher ratio(headcount basis) of Lebanon?
Ensure brevity in your answer.  39.33. In the year 2004, what is the difference between the Pupil-teacher ratio(headcount basis) in Eritrea and Pupil-teacher ratio(headcount basis) in Lesotho?
Your answer should be very brief. 22.71. In the year 2004, what is the difference between the Pupil-teacher ratio(headcount basis) of Eritrea and Pupil-teacher ratio(headcount basis) of Nigeria?
Offer a very short reply. 7.22. In the year 2004, what is the difference between the Pupil-teacher ratio(headcount basis) of Lebanon and Pupil-teacher ratio(headcount basis) of Lesotho?
Ensure brevity in your answer.  -16.62. In the year 2004, what is the difference between the Pupil-teacher ratio(headcount basis) in Lebanon and Pupil-teacher ratio(headcount basis) in Nigeria?
Keep it short and to the point. -32.11. In the year 2004, what is the difference between the Pupil-teacher ratio(headcount basis) of Lesotho and Pupil-teacher ratio(headcount basis) of Nigeria?
Make the answer very short. -15.5. In the year 2005, what is the difference between the Pupil-teacher ratio(headcount basis) in Eritrea and Pupil-teacher ratio(headcount basis) in Lebanon?
Keep it short and to the point. 42.31. In the year 2005, what is the difference between the Pupil-teacher ratio(headcount basis) of Eritrea and Pupil-teacher ratio(headcount basis) of Lesotho?
Keep it short and to the point. 24.31. In the year 2005, what is the difference between the Pupil-teacher ratio(headcount basis) of Eritrea and Pupil-teacher ratio(headcount basis) of Nigeria?
Ensure brevity in your answer.  11.18. In the year 2005, what is the difference between the Pupil-teacher ratio(headcount basis) of Lebanon and Pupil-teacher ratio(headcount basis) of Lesotho?
Your answer should be compact. -18. In the year 2005, what is the difference between the Pupil-teacher ratio(headcount basis) of Lebanon and Pupil-teacher ratio(headcount basis) of Nigeria?
Offer a very short reply. -31.12. In the year 2005, what is the difference between the Pupil-teacher ratio(headcount basis) of Lesotho and Pupil-teacher ratio(headcount basis) of Nigeria?
Your response must be concise. -13.13. In the year 2006, what is the difference between the Pupil-teacher ratio(headcount basis) of Eritrea and Pupil-teacher ratio(headcount basis) of Lebanon?
Offer a very short reply. 45.21. In the year 2006, what is the difference between the Pupil-teacher ratio(headcount basis) in Eritrea and Pupil-teacher ratio(headcount basis) in Lesotho?
Your answer should be compact. 28.6. In the year 2006, what is the difference between the Pupil-teacher ratio(headcount basis) in Eritrea and Pupil-teacher ratio(headcount basis) in Nigeria?
Provide a succinct answer. 22.54. In the year 2006, what is the difference between the Pupil-teacher ratio(headcount basis) in Lebanon and Pupil-teacher ratio(headcount basis) in Lesotho?
Your answer should be very brief. -16.61. In the year 2006, what is the difference between the Pupil-teacher ratio(headcount basis) in Lebanon and Pupil-teacher ratio(headcount basis) in Nigeria?
Provide a short and direct response. -22.67. In the year 2006, what is the difference between the Pupil-teacher ratio(headcount basis) in Lesotho and Pupil-teacher ratio(headcount basis) in Nigeria?
Provide a short and direct response. -6.06. In the year 2007, what is the difference between the Pupil-teacher ratio(headcount basis) of Eritrea and Pupil-teacher ratio(headcount basis) of Lebanon?
Give a very brief answer. 40.15. In the year 2007, what is the difference between the Pupil-teacher ratio(headcount basis) in Eritrea and Pupil-teacher ratio(headcount basis) in Lesotho?
Ensure brevity in your answer.  23.95. In the year 2007, what is the difference between the Pupil-teacher ratio(headcount basis) of Eritrea and Pupil-teacher ratio(headcount basis) of Nigeria?
Provide a succinct answer. 20.91. In the year 2007, what is the difference between the Pupil-teacher ratio(headcount basis) of Lebanon and Pupil-teacher ratio(headcount basis) of Lesotho?
Your answer should be very brief. -16.19. In the year 2007, what is the difference between the Pupil-teacher ratio(headcount basis) of Lebanon and Pupil-teacher ratio(headcount basis) of Nigeria?
Ensure brevity in your answer.  -19.24. In the year 2007, what is the difference between the Pupil-teacher ratio(headcount basis) of Lesotho and Pupil-teacher ratio(headcount basis) of Nigeria?
Your answer should be very brief. -3.04. In the year 2010, what is the difference between the Pupil-teacher ratio(headcount basis) in Eritrea and Pupil-teacher ratio(headcount basis) in Lebanon?
Keep it short and to the point. 29.74. In the year 2010, what is the difference between the Pupil-teacher ratio(headcount basis) of Eritrea and Pupil-teacher ratio(headcount basis) of Lesotho?
Provide a short and direct response. 14.2. In the year 2010, what is the difference between the Pupil-teacher ratio(headcount basis) of Eritrea and Pupil-teacher ratio(headcount basis) of Nigeria?
Offer a very short reply. 5.6. In the year 2010, what is the difference between the Pupil-teacher ratio(headcount basis) of Lebanon and Pupil-teacher ratio(headcount basis) of Lesotho?
Provide a short and direct response. -15.54. In the year 2010, what is the difference between the Pupil-teacher ratio(headcount basis) of Lebanon and Pupil-teacher ratio(headcount basis) of Nigeria?
Offer a terse response. -24.14. In the year 2010, what is the difference between the Pupil-teacher ratio(headcount basis) in Lesotho and Pupil-teacher ratio(headcount basis) in Nigeria?
Give a very brief answer. -8.6. What is the ratio of the Pupil-teacher ratio(headcount basis) in Eritrea in 2001 to that in 2002?
Give a very brief answer. 1.06. What is the ratio of the Pupil-teacher ratio(headcount basis) in Lebanon in 2001 to that in 2002?
Provide a succinct answer. 1.02. What is the ratio of the Pupil-teacher ratio(headcount basis) of Nigeria in 2001 to that in 2002?
Offer a very short reply. 1.04. What is the ratio of the Pupil-teacher ratio(headcount basis) of Eritrea in 2001 to that in 2004?
Your answer should be very brief. 1.1. What is the ratio of the Pupil-teacher ratio(headcount basis) in Lebanon in 2001 to that in 2004?
Provide a succinct answer. 0.89. What is the ratio of the Pupil-teacher ratio(headcount basis) in Lesotho in 2001 to that in 2004?
Offer a terse response. 0.91. What is the ratio of the Pupil-teacher ratio(headcount basis) in Nigeria in 2001 to that in 2004?
Offer a terse response. 0.81. What is the ratio of the Pupil-teacher ratio(headcount basis) of Eritrea in 2001 to that in 2005?
Your answer should be compact. 1.02. What is the ratio of the Pupil-teacher ratio(headcount basis) of Lebanon in 2001 to that in 2005?
Keep it short and to the point. 0.83. What is the ratio of the Pupil-teacher ratio(headcount basis) of Lesotho in 2001 to that in 2005?
Your answer should be compact. 0.85. What is the ratio of the Pupil-teacher ratio(headcount basis) in Nigeria in 2001 to that in 2005?
Your answer should be compact. 0.81. What is the ratio of the Pupil-teacher ratio(headcount basis) in Eritrea in 2001 to that in 2006?
Make the answer very short. 0.96. What is the ratio of the Pupil-teacher ratio(headcount basis) of Lebanon in 2001 to that in 2006?
Offer a terse response. 0.82. What is the ratio of the Pupil-teacher ratio(headcount basis) in Lesotho in 2001 to that in 2006?
Your response must be concise. 0.89. What is the ratio of the Pupil-teacher ratio(headcount basis) of Nigeria in 2001 to that in 2006?
Offer a very short reply. 1.03. What is the ratio of the Pupil-teacher ratio(headcount basis) of Eritrea in 2001 to that in 2007?
Provide a succinct answer. 1.06. What is the ratio of the Pupil-teacher ratio(headcount basis) in Lebanon in 2001 to that in 2007?
Your answer should be compact. 0.82. What is the ratio of the Pupil-teacher ratio(headcount basis) of Lesotho in 2001 to that in 2007?
Your response must be concise. 0.9. What is the ratio of the Pupil-teacher ratio(headcount basis) in Nigeria in 2001 to that in 2007?
Your answer should be compact. 1.15. What is the ratio of the Pupil-teacher ratio(headcount basis) of Eritrea in 2001 to that in 2010?
Make the answer very short. 1.36. What is the ratio of the Pupil-teacher ratio(headcount basis) of Lebanon in 2001 to that in 2010?
Offer a very short reply. 0.84. What is the ratio of the Pupil-teacher ratio(headcount basis) of Lesotho in 2001 to that in 2010?
Your response must be concise. 0.94. What is the ratio of the Pupil-teacher ratio(headcount basis) in Eritrea in 2002 to that in 2004?
Make the answer very short. 1.03. What is the ratio of the Pupil-teacher ratio(headcount basis) in Lebanon in 2002 to that in 2004?
Your answer should be compact. 0.87. What is the ratio of the Pupil-teacher ratio(headcount basis) of Lesotho in 2002 to that in 2004?
Your response must be concise. 0.92. What is the ratio of the Pupil-teacher ratio(headcount basis) in Nigeria in 2002 to that in 2004?
Your answer should be compact. 0.77. What is the ratio of the Pupil-teacher ratio(headcount basis) of Eritrea in 2002 to that in 2005?
Keep it short and to the point. 0.96. What is the ratio of the Pupil-teacher ratio(headcount basis) in Lebanon in 2002 to that in 2005?
Offer a terse response. 0.82. What is the ratio of the Pupil-teacher ratio(headcount basis) of Lesotho in 2002 to that in 2005?
Keep it short and to the point. 0.86. What is the ratio of the Pupil-teacher ratio(headcount basis) of Nigeria in 2002 to that in 2005?
Your answer should be compact. 0.78. What is the ratio of the Pupil-teacher ratio(headcount basis) of Eritrea in 2002 to that in 2006?
Keep it short and to the point. 0.91. What is the ratio of the Pupil-teacher ratio(headcount basis) of Lebanon in 2002 to that in 2006?
Give a very brief answer. 0.8. What is the ratio of the Pupil-teacher ratio(headcount basis) in Lesotho in 2002 to that in 2006?
Offer a very short reply. 0.9. What is the ratio of the Pupil-teacher ratio(headcount basis) of Nigeria in 2002 to that in 2006?
Your answer should be compact. 0.99. What is the ratio of the Pupil-teacher ratio(headcount basis) in Lebanon in 2002 to that in 2007?
Keep it short and to the point. 0.8. What is the ratio of the Pupil-teacher ratio(headcount basis) in Lesotho in 2002 to that in 2007?
Provide a short and direct response. 0.91. What is the ratio of the Pupil-teacher ratio(headcount basis) in Nigeria in 2002 to that in 2007?
Give a very brief answer. 1.11. What is the ratio of the Pupil-teacher ratio(headcount basis) in Eritrea in 2002 to that in 2010?
Provide a succinct answer. 1.27. What is the ratio of the Pupil-teacher ratio(headcount basis) of Lebanon in 2002 to that in 2010?
Ensure brevity in your answer.  0.83. What is the ratio of the Pupil-teacher ratio(headcount basis) of Lesotho in 2002 to that in 2010?
Provide a succinct answer. 0.95. What is the ratio of the Pupil-teacher ratio(headcount basis) in Nigeria in 2002 to that in 2010?
Ensure brevity in your answer.  0.95. What is the ratio of the Pupil-teacher ratio(headcount basis) of Eritrea in 2004 to that in 2005?
Provide a succinct answer. 0.93. What is the ratio of the Pupil-teacher ratio(headcount basis) in Lebanon in 2004 to that in 2005?
Provide a short and direct response. 0.94. What is the ratio of the Pupil-teacher ratio(headcount basis) in Lesotho in 2004 to that in 2005?
Offer a terse response. 0.93. What is the ratio of the Pupil-teacher ratio(headcount basis) in Nigeria in 2004 to that in 2005?
Give a very brief answer. 1.01. What is the ratio of the Pupil-teacher ratio(headcount basis) in Eritrea in 2004 to that in 2006?
Your answer should be very brief. 0.88. What is the ratio of the Pupil-teacher ratio(headcount basis) in Lebanon in 2004 to that in 2006?
Keep it short and to the point. 0.93. What is the ratio of the Pupil-teacher ratio(headcount basis) in Lesotho in 2004 to that in 2006?
Your response must be concise. 0.97. What is the ratio of the Pupil-teacher ratio(headcount basis) of Nigeria in 2004 to that in 2006?
Provide a short and direct response. 1.28. What is the ratio of the Pupil-teacher ratio(headcount basis) of Eritrea in 2004 to that in 2007?
Provide a short and direct response. 0.97. What is the ratio of the Pupil-teacher ratio(headcount basis) in Lebanon in 2004 to that in 2007?
Ensure brevity in your answer.  0.92. What is the ratio of the Pupil-teacher ratio(headcount basis) of Nigeria in 2004 to that in 2007?
Offer a very short reply. 1.43. What is the ratio of the Pupil-teacher ratio(headcount basis) of Eritrea in 2004 to that in 2010?
Make the answer very short. 1.24. What is the ratio of the Pupil-teacher ratio(headcount basis) in Lebanon in 2004 to that in 2010?
Your response must be concise. 0.95. What is the ratio of the Pupil-teacher ratio(headcount basis) of Lesotho in 2004 to that in 2010?
Make the answer very short. 1.03. What is the ratio of the Pupil-teacher ratio(headcount basis) in Nigeria in 2004 to that in 2010?
Provide a succinct answer. 1.23. What is the ratio of the Pupil-teacher ratio(headcount basis) of Eritrea in 2005 to that in 2006?
Keep it short and to the point. 0.94. What is the ratio of the Pupil-teacher ratio(headcount basis) in Lebanon in 2005 to that in 2006?
Offer a very short reply. 0.98. What is the ratio of the Pupil-teacher ratio(headcount basis) in Lesotho in 2005 to that in 2006?
Make the answer very short. 1.05. What is the ratio of the Pupil-teacher ratio(headcount basis) in Nigeria in 2005 to that in 2006?
Give a very brief answer. 1.26. What is the ratio of the Pupil-teacher ratio(headcount basis) of Eritrea in 2005 to that in 2007?
Offer a very short reply. 1.04. What is the ratio of the Pupil-teacher ratio(headcount basis) in Lebanon in 2005 to that in 2007?
Your answer should be compact. 0.98. What is the ratio of the Pupil-teacher ratio(headcount basis) in Lesotho in 2005 to that in 2007?
Your response must be concise. 1.06. What is the ratio of the Pupil-teacher ratio(headcount basis) of Nigeria in 2005 to that in 2007?
Your answer should be very brief. 1.41. What is the ratio of the Pupil-teacher ratio(headcount basis) of Eritrea in 2005 to that in 2010?
Offer a very short reply. 1.33. What is the ratio of the Pupil-teacher ratio(headcount basis) in Lesotho in 2005 to that in 2010?
Make the answer very short. 1.1. What is the ratio of the Pupil-teacher ratio(headcount basis) of Nigeria in 2005 to that in 2010?
Give a very brief answer. 1.21. What is the ratio of the Pupil-teacher ratio(headcount basis) in Eritrea in 2006 to that in 2007?
Offer a very short reply. 1.1. What is the ratio of the Pupil-teacher ratio(headcount basis) in Lesotho in 2006 to that in 2007?
Provide a succinct answer. 1.02. What is the ratio of the Pupil-teacher ratio(headcount basis) in Nigeria in 2006 to that in 2007?
Keep it short and to the point. 1.12. What is the ratio of the Pupil-teacher ratio(headcount basis) of Eritrea in 2006 to that in 2010?
Keep it short and to the point. 1.41. What is the ratio of the Pupil-teacher ratio(headcount basis) of Lebanon in 2006 to that in 2010?
Offer a very short reply. 1.03. What is the ratio of the Pupil-teacher ratio(headcount basis) in Lesotho in 2006 to that in 2010?
Keep it short and to the point. 1.05. What is the ratio of the Pupil-teacher ratio(headcount basis) of Nigeria in 2006 to that in 2010?
Offer a very short reply. 0.96. What is the ratio of the Pupil-teacher ratio(headcount basis) in Eritrea in 2007 to that in 2010?
Provide a succinct answer. 1.28. What is the ratio of the Pupil-teacher ratio(headcount basis) in Lebanon in 2007 to that in 2010?
Offer a terse response. 1.03. What is the ratio of the Pupil-teacher ratio(headcount basis) of Lesotho in 2007 to that in 2010?
Keep it short and to the point. 1.04. What is the ratio of the Pupil-teacher ratio(headcount basis) of Nigeria in 2007 to that in 2010?
Ensure brevity in your answer.  0.86. What is the difference between the highest and the second highest Pupil-teacher ratio(headcount basis) in Eritrea?
Keep it short and to the point. 1.95. What is the difference between the highest and the second highest Pupil-teacher ratio(headcount basis) in Lebanon?
Keep it short and to the point. 0.02. What is the difference between the highest and the second highest Pupil-teacher ratio(headcount basis) of Lesotho?
Your answer should be very brief. 1.25. What is the difference between the highest and the second highest Pupil-teacher ratio(headcount basis) in Nigeria?
Provide a short and direct response. 0.45. What is the difference between the highest and the lowest Pupil-teacher ratio(headcount basis) of Eritrea?
Your answer should be very brief. 15.71. What is the difference between the highest and the lowest Pupil-teacher ratio(headcount basis) of Lebanon?
Give a very brief answer. 1.81. What is the difference between the highest and the lowest Pupil-teacher ratio(headcount basis) in Lesotho?
Your response must be concise. 4.1. What is the difference between the highest and the lowest Pupil-teacher ratio(headcount basis) in Nigeria?
Offer a terse response. 12.18. 